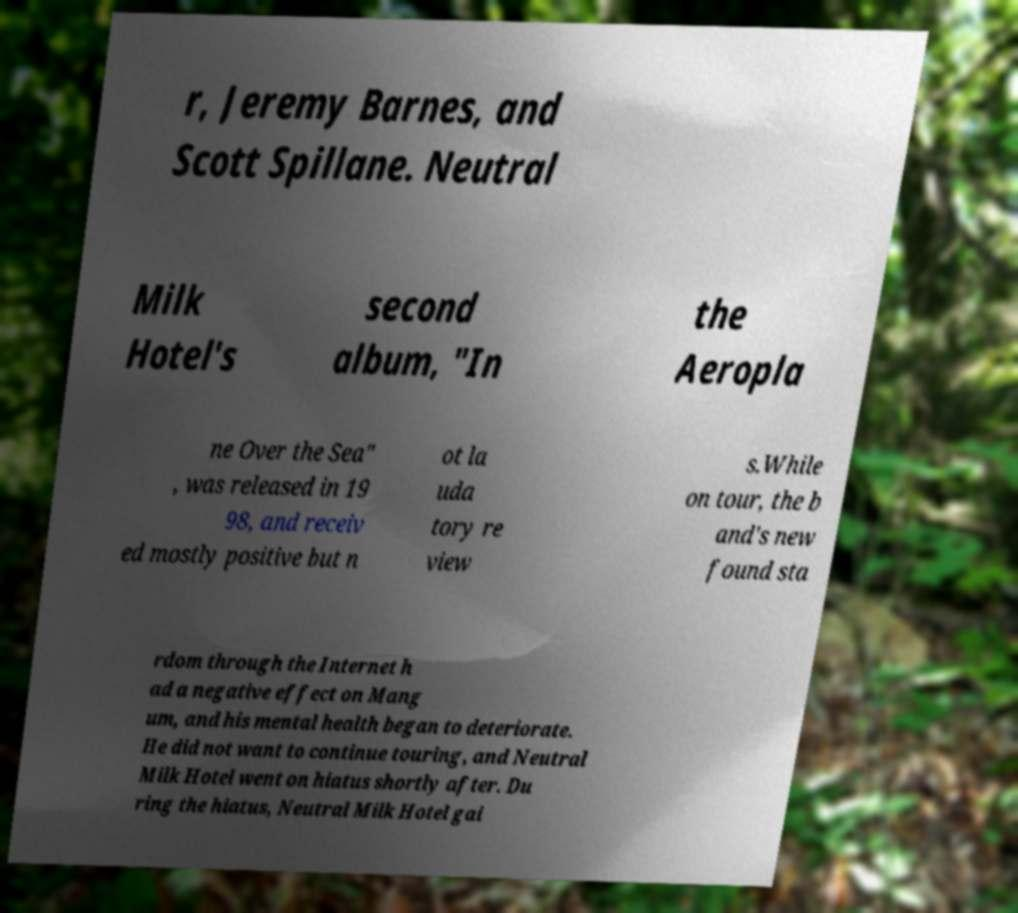Could you extract and type out the text from this image? r, Jeremy Barnes, and Scott Spillane. Neutral Milk Hotel's second album, "In the Aeropla ne Over the Sea" , was released in 19 98, and receiv ed mostly positive but n ot la uda tory re view s.While on tour, the b and's new found sta rdom through the Internet h ad a negative effect on Mang um, and his mental health began to deteriorate. He did not want to continue touring, and Neutral Milk Hotel went on hiatus shortly after. Du ring the hiatus, Neutral Milk Hotel gai 